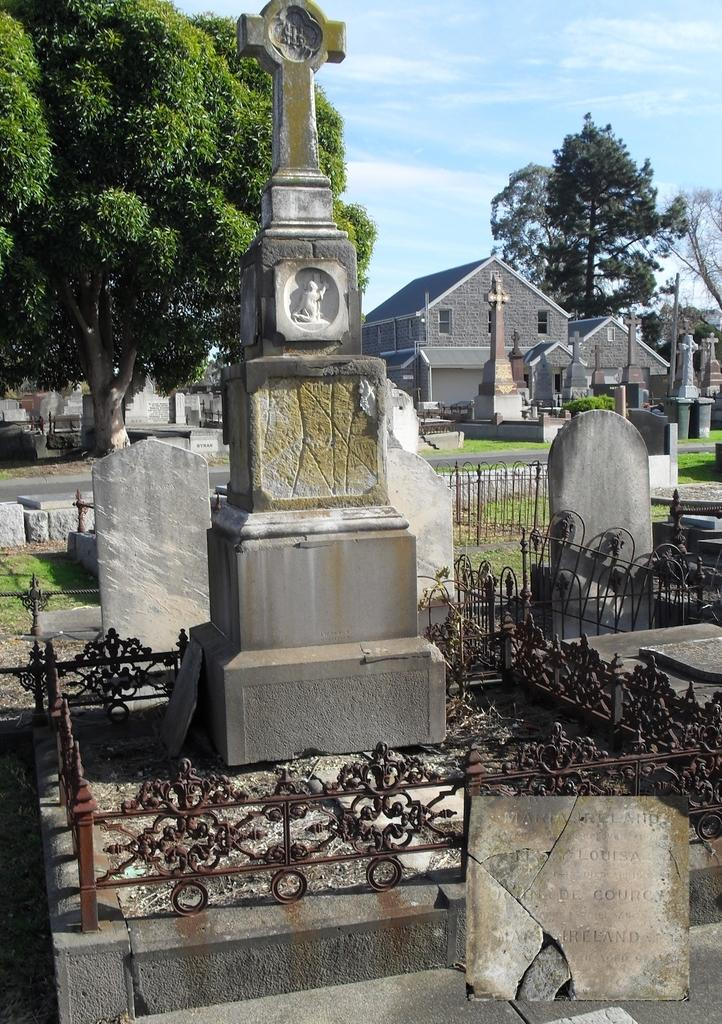What is the main subject in the center of the image? There is a graveyard in the center of the image. What can be seen in the background of the image? There are buildings, trees, a road, and the sky visible in the background of the image. Are there any clouds in the sky? Yes, clouds are present in the sky. Where is the faucet located in the image? There is no faucet present in the image. How many lizards can be seen crawling on the graveyard in the image? There are no lizards present in the image. 